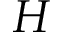<formula> <loc_0><loc_0><loc_500><loc_500>H</formula> 